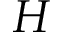<formula> <loc_0><loc_0><loc_500><loc_500>H</formula> 